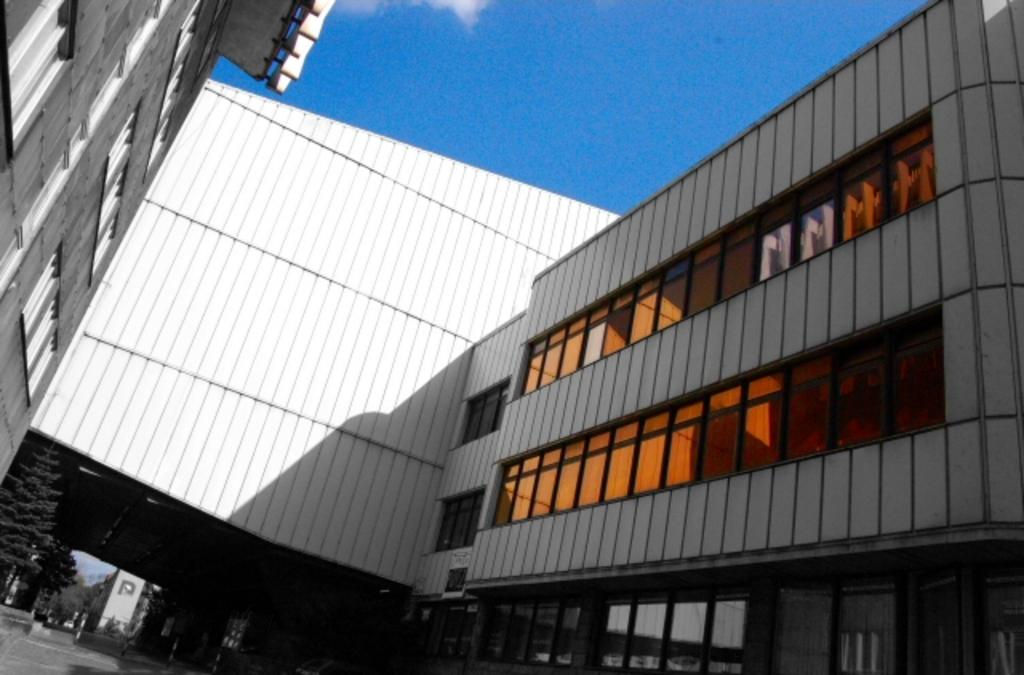What type of structures can be seen in the image? There are buildings in the image. What other natural elements are present in the image? There are trees in the image. What architectural features can be observed on the buildings? There are glass windows and doors in the image. What is visible in the background of the image? The sky is visible in the image. Can you describe the beggar sitting under the tree in the image? There is no beggar present in the image; it only features buildings, trees, glass windows, doors, and the sky. 